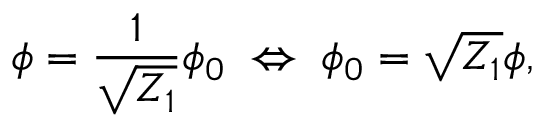Convert formula to latex. <formula><loc_0><loc_0><loc_500><loc_500>\phi = \frac { 1 } { \sqrt { Z _ { 1 } } } \phi _ { 0 } \, \Leftrightarrow \, \phi _ { 0 } = \sqrt { Z _ { 1 } } \phi ,</formula> 